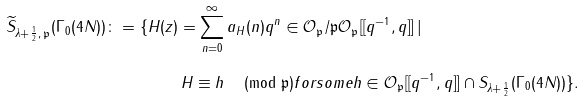Convert formula to latex. <formula><loc_0><loc_0><loc_500><loc_500>\widetilde { S } _ { \lambda + \frac { 1 } { 2 } , \, \mathfrak { p } } ( \Gamma _ { 0 } ( 4 N ) ) \colon = \{ H ( z ) & = \sum _ { n = 0 } ^ { \infty } a _ { H } ( n ) q ^ { n } \in \mathcal { O } _ { \mathfrak { p } } / \mathfrak { p } \mathcal { O } _ { \mathfrak { p } } [ [ q ^ { - 1 } , q ] ] \, | \\ & \, H \equiv h \, \pmod { \mathfrak { p } } f o r s o m e h \in \mathcal { O } _ { \mathfrak { p } } [ [ q ^ { - 1 } , q ] ] \cap S _ { \lambda + \frac { 1 } { 2 } } ( \Gamma _ { 0 } ( 4 N ) ) \} .</formula> 